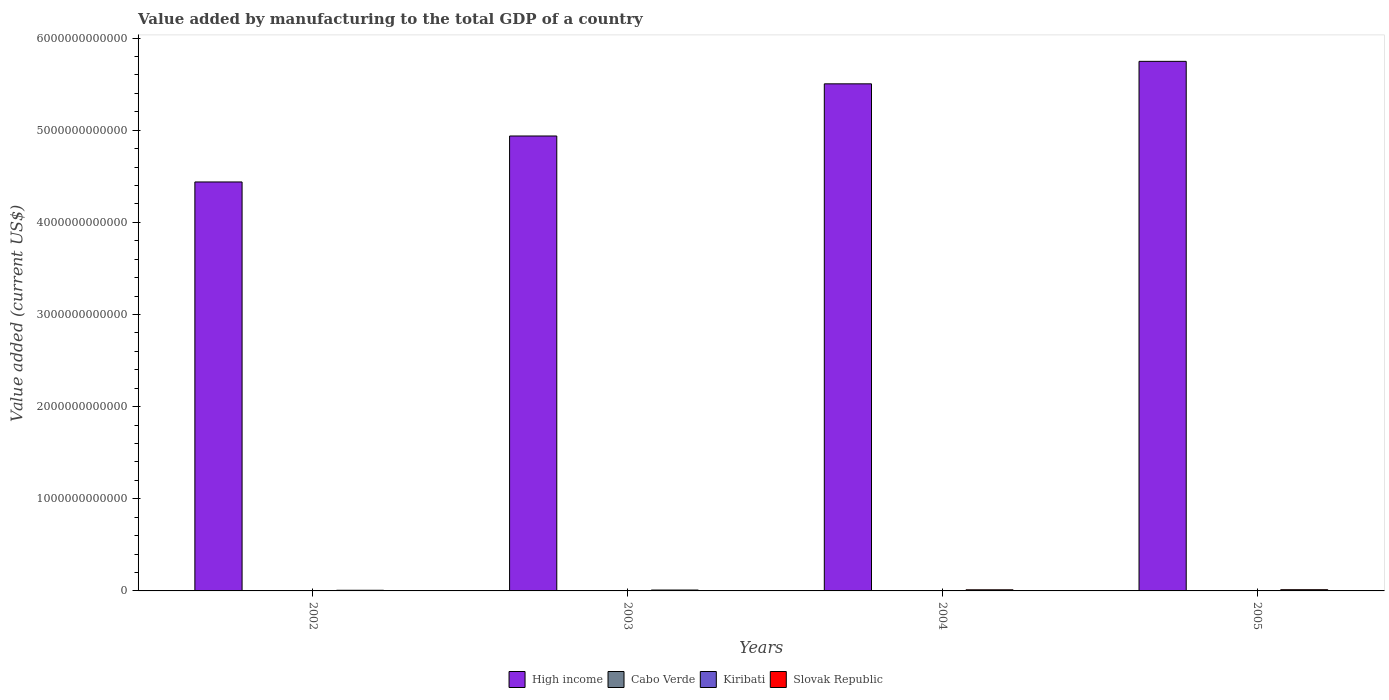How many different coloured bars are there?
Ensure brevity in your answer.  4. Are the number of bars per tick equal to the number of legend labels?
Your answer should be compact. Yes. How many bars are there on the 3rd tick from the left?
Offer a very short reply. 4. In how many cases, is the number of bars for a given year not equal to the number of legend labels?
Offer a terse response. 0. What is the value added by manufacturing to the total GDP in Kiribati in 2002?
Give a very brief answer. 2.85e+06. Across all years, what is the maximum value added by manufacturing to the total GDP in High income?
Your answer should be compact. 5.75e+12. Across all years, what is the minimum value added by manufacturing to the total GDP in Kiribati?
Your answer should be compact. 2.85e+06. What is the total value added by manufacturing to the total GDP in Cabo Verde in the graph?
Offer a terse response. 2.26e+08. What is the difference between the value added by manufacturing to the total GDP in Slovak Republic in 2004 and that in 2005?
Offer a very short reply. -1.05e+09. What is the difference between the value added by manufacturing to the total GDP in Slovak Republic in 2003 and the value added by manufacturing to the total GDP in Cabo Verde in 2002?
Offer a very short reply. 9.59e+09. What is the average value added by manufacturing to the total GDP in Slovak Republic per year?
Your response must be concise. 1.05e+1. In the year 2005, what is the difference between the value added by manufacturing to the total GDP in High income and value added by manufacturing to the total GDP in Cabo Verde?
Your answer should be very brief. 5.75e+12. What is the ratio of the value added by manufacturing to the total GDP in Kiribati in 2002 to that in 2003?
Offer a very short reply. 0.78. Is the value added by manufacturing to the total GDP in High income in 2004 less than that in 2005?
Your answer should be compact. Yes. What is the difference between the highest and the second highest value added by manufacturing to the total GDP in Slovak Republic?
Your response must be concise. 1.05e+09. What is the difference between the highest and the lowest value added by manufacturing to the total GDP in Cabo Verde?
Provide a succinct answer. 1.59e+07. In how many years, is the value added by manufacturing to the total GDP in Cabo Verde greater than the average value added by manufacturing to the total GDP in Cabo Verde taken over all years?
Give a very brief answer. 3. What does the 3rd bar from the left in 2005 represents?
Offer a very short reply. Kiribati. What does the 1st bar from the right in 2003 represents?
Provide a succinct answer. Slovak Republic. How many years are there in the graph?
Your response must be concise. 4. What is the difference between two consecutive major ticks on the Y-axis?
Keep it short and to the point. 1.00e+12. Are the values on the major ticks of Y-axis written in scientific E-notation?
Ensure brevity in your answer.  No. How are the legend labels stacked?
Your response must be concise. Horizontal. What is the title of the graph?
Your answer should be compact. Value added by manufacturing to the total GDP of a country. Does "Cameroon" appear as one of the legend labels in the graph?
Give a very brief answer. No. What is the label or title of the Y-axis?
Provide a short and direct response. Value added (current US$). What is the Value added (current US$) of High income in 2002?
Offer a very short reply. 4.44e+12. What is the Value added (current US$) in Cabo Verde in 2002?
Keep it short and to the point. 4.68e+07. What is the Value added (current US$) of Kiribati in 2002?
Give a very brief answer. 2.85e+06. What is the Value added (current US$) in Slovak Republic in 2002?
Provide a succinct answer. 7.10e+09. What is the Value added (current US$) in High income in 2003?
Offer a terse response. 4.94e+12. What is the Value added (current US$) of Cabo Verde in 2003?
Offer a very short reply. 5.70e+07. What is the Value added (current US$) in Kiribati in 2003?
Give a very brief answer. 3.66e+06. What is the Value added (current US$) in Slovak Republic in 2003?
Keep it short and to the point. 9.63e+09. What is the Value added (current US$) of High income in 2004?
Provide a short and direct response. 5.50e+12. What is the Value added (current US$) in Cabo Verde in 2004?
Your answer should be compact. 5.92e+07. What is the Value added (current US$) of Kiribati in 2004?
Your answer should be very brief. 4.54e+06. What is the Value added (current US$) of Slovak Republic in 2004?
Ensure brevity in your answer.  1.21e+1. What is the Value added (current US$) of High income in 2005?
Provide a short and direct response. 5.75e+12. What is the Value added (current US$) in Cabo Verde in 2005?
Ensure brevity in your answer.  6.27e+07. What is the Value added (current US$) in Kiribati in 2005?
Your answer should be very brief. 5.31e+06. What is the Value added (current US$) of Slovak Republic in 2005?
Make the answer very short. 1.31e+1. Across all years, what is the maximum Value added (current US$) of High income?
Your response must be concise. 5.75e+12. Across all years, what is the maximum Value added (current US$) in Cabo Verde?
Your answer should be compact. 6.27e+07. Across all years, what is the maximum Value added (current US$) in Kiribati?
Your response must be concise. 5.31e+06. Across all years, what is the maximum Value added (current US$) in Slovak Republic?
Offer a very short reply. 1.31e+1. Across all years, what is the minimum Value added (current US$) in High income?
Your answer should be compact. 4.44e+12. Across all years, what is the minimum Value added (current US$) of Cabo Verde?
Your answer should be very brief. 4.68e+07. Across all years, what is the minimum Value added (current US$) in Kiribati?
Your answer should be very brief. 2.85e+06. Across all years, what is the minimum Value added (current US$) of Slovak Republic?
Your answer should be very brief. 7.10e+09. What is the total Value added (current US$) of High income in the graph?
Your answer should be very brief. 2.06e+13. What is the total Value added (current US$) of Cabo Verde in the graph?
Keep it short and to the point. 2.26e+08. What is the total Value added (current US$) in Kiribati in the graph?
Make the answer very short. 1.64e+07. What is the total Value added (current US$) in Slovak Republic in the graph?
Keep it short and to the point. 4.19e+1. What is the difference between the Value added (current US$) in High income in 2002 and that in 2003?
Your answer should be very brief. -4.99e+11. What is the difference between the Value added (current US$) in Cabo Verde in 2002 and that in 2003?
Offer a terse response. -1.02e+07. What is the difference between the Value added (current US$) of Kiribati in 2002 and that in 2003?
Your answer should be very brief. -8.19e+05. What is the difference between the Value added (current US$) in Slovak Republic in 2002 and that in 2003?
Your answer should be compact. -2.53e+09. What is the difference between the Value added (current US$) of High income in 2002 and that in 2004?
Make the answer very short. -1.06e+12. What is the difference between the Value added (current US$) in Cabo Verde in 2002 and that in 2004?
Ensure brevity in your answer.  -1.24e+07. What is the difference between the Value added (current US$) of Kiribati in 2002 and that in 2004?
Offer a terse response. -1.69e+06. What is the difference between the Value added (current US$) of Slovak Republic in 2002 and that in 2004?
Your answer should be very brief. -4.96e+09. What is the difference between the Value added (current US$) of High income in 2002 and that in 2005?
Keep it short and to the point. -1.31e+12. What is the difference between the Value added (current US$) in Cabo Verde in 2002 and that in 2005?
Make the answer very short. -1.59e+07. What is the difference between the Value added (current US$) of Kiribati in 2002 and that in 2005?
Offer a very short reply. -2.47e+06. What is the difference between the Value added (current US$) of Slovak Republic in 2002 and that in 2005?
Provide a short and direct response. -6.01e+09. What is the difference between the Value added (current US$) of High income in 2003 and that in 2004?
Provide a short and direct response. -5.66e+11. What is the difference between the Value added (current US$) in Cabo Verde in 2003 and that in 2004?
Ensure brevity in your answer.  -2.22e+06. What is the difference between the Value added (current US$) in Kiribati in 2003 and that in 2004?
Your answer should be very brief. -8.74e+05. What is the difference between the Value added (current US$) in Slovak Republic in 2003 and that in 2004?
Make the answer very short. -2.42e+09. What is the difference between the Value added (current US$) of High income in 2003 and that in 2005?
Offer a very short reply. -8.10e+11. What is the difference between the Value added (current US$) of Cabo Verde in 2003 and that in 2005?
Your answer should be compact. -5.71e+06. What is the difference between the Value added (current US$) in Kiribati in 2003 and that in 2005?
Offer a terse response. -1.65e+06. What is the difference between the Value added (current US$) of Slovak Republic in 2003 and that in 2005?
Give a very brief answer. -3.47e+09. What is the difference between the Value added (current US$) in High income in 2004 and that in 2005?
Make the answer very short. -2.44e+11. What is the difference between the Value added (current US$) of Cabo Verde in 2004 and that in 2005?
Ensure brevity in your answer.  -3.49e+06. What is the difference between the Value added (current US$) of Kiribati in 2004 and that in 2005?
Your answer should be compact. -7.76e+05. What is the difference between the Value added (current US$) of Slovak Republic in 2004 and that in 2005?
Your answer should be very brief. -1.05e+09. What is the difference between the Value added (current US$) in High income in 2002 and the Value added (current US$) in Cabo Verde in 2003?
Provide a short and direct response. 4.44e+12. What is the difference between the Value added (current US$) of High income in 2002 and the Value added (current US$) of Kiribati in 2003?
Ensure brevity in your answer.  4.44e+12. What is the difference between the Value added (current US$) in High income in 2002 and the Value added (current US$) in Slovak Republic in 2003?
Your answer should be very brief. 4.43e+12. What is the difference between the Value added (current US$) of Cabo Verde in 2002 and the Value added (current US$) of Kiribati in 2003?
Offer a terse response. 4.32e+07. What is the difference between the Value added (current US$) in Cabo Verde in 2002 and the Value added (current US$) in Slovak Republic in 2003?
Make the answer very short. -9.59e+09. What is the difference between the Value added (current US$) in Kiribati in 2002 and the Value added (current US$) in Slovak Republic in 2003?
Make the answer very short. -9.63e+09. What is the difference between the Value added (current US$) in High income in 2002 and the Value added (current US$) in Cabo Verde in 2004?
Keep it short and to the point. 4.44e+12. What is the difference between the Value added (current US$) in High income in 2002 and the Value added (current US$) in Kiribati in 2004?
Keep it short and to the point. 4.44e+12. What is the difference between the Value added (current US$) in High income in 2002 and the Value added (current US$) in Slovak Republic in 2004?
Offer a terse response. 4.43e+12. What is the difference between the Value added (current US$) of Cabo Verde in 2002 and the Value added (current US$) of Kiribati in 2004?
Provide a short and direct response. 4.23e+07. What is the difference between the Value added (current US$) in Cabo Verde in 2002 and the Value added (current US$) in Slovak Republic in 2004?
Your answer should be compact. -1.20e+1. What is the difference between the Value added (current US$) in Kiribati in 2002 and the Value added (current US$) in Slovak Republic in 2004?
Keep it short and to the point. -1.21e+1. What is the difference between the Value added (current US$) of High income in 2002 and the Value added (current US$) of Cabo Verde in 2005?
Provide a succinct answer. 4.44e+12. What is the difference between the Value added (current US$) of High income in 2002 and the Value added (current US$) of Kiribati in 2005?
Keep it short and to the point. 4.44e+12. What is the difference between the Value added (current US$) of High income in 2002 and the Value added (current US$) of Slovak Republic in 2005?
Make the answer very short. 4.43e+12. What is the difference between the Value added (current US$) of Cabo Verde in 2002 and the Value added (current US$) of Kiribati in 2005?
Provide a succinct answer. 4.15e+07. What is the difference between the Value added (current US$) of Cabo Verde in 2002 and the Value added (current US$) of Slovak Republic in 2005?
Keep it short and to the point. -1.31e+1. What is the difference between the Value added (current US$) in Kiribati in 2002 and the Value added (current US$) in Slovak Republic in 2005?
Your response must be concise. -1.31e+1. What is the difference between the Value added (current US$) in High income in 2003 and the Value added (current US$) in Cabo Verde in 2004?
Your answer should be very brief. 4.94e+12. What is the difference between the Value added (current US$) in High income in 2003 and the Value added (current US$) in Kiribati in 2004?
Offer a very short reply. 4.94e+12. What is the difference between the Value added (current US$) in High income in 2003 and the Value added (current US$) in Slovak Republic in 2004?
Give a very brief answer. 4.93e+12. What is the difference between the Value added (current US$) of Cabo Verde in 2003 and the Value added (current US$) of Kiribati in 2004?
Keep it short and to the point. 5.25e+07. What is the difference between the Value added (current US$) of Cabo Verde in 2003 and the Value added (current US$) of Slovak Republic in 2004?
Ensure brevity in your answer.  -1.20e+1. What is the difference between the Value added (current US$) in Kiribati in 2003 and the Value added (current US$) in Slovak Republic in 2004?
Your answer should be compact. -1.21e+1. What is the difference between the Value added (current US$) in High income in 2003 and the Value added (current US$) in Cabo Verde in 2005?
Make the answer very short. 4.94e+12. What is the difference between the Value added (current US$) in High income in 2003 and the Value added (current US$) in Kiribati in 2005?
Your answer should be compact. 4.94e+12. What is the difference between the Value added (current US$) of High income in 2003 and the Value added (current US$) of Slovak Republic in 2005?
Your answer should be very brief. 4.92e+12. What is the difference between the Value added (current US$) in Cabo Verde in 2003 and the Value added (current US$) in Kiribati in 2005?
Your answer should be compact. 5.17e+07. What is the difference between the Value added (current US$) of Cabo Verde in 2003 and the Value added (current US$) of Slovak Republic in 2005?
Provide a succinct answer. -1.31e+1. What is the difference between the Value added (current US$) of Kiribati in 2003 and the Value added (current US$) of Slovak Republic in 2005?
Keep it short and to the point. -1.31e+1. What is the difference between the Value added (current US$) of High income in 2004 and the Value added (current US$) of Cabo Verde in 2005?
Your answer should be very brief. 5.50e+12. What is the difference between the Value added (current US$) in High income in 2004 and the Value added (current US$) in Kiribati in 2005?
Provide a short and direct response. 5.50e+12. What is the difference between the Value added (current US$) in High income in 2004 and the Value added (current US$) in Slovak Republic in 2005?
Give a very brief answer. 5.49e+12. What is the difference between the Value added (current US$) in Cabo Verde in 2004 and the Value added (current US$) in Kiribati in 2005?
Make the answer very short. 5.39e+07. What is the difference between the Value added (current US$) in Cabo Verde in 2004 and the Value added (current US$) in Slovak Republic in 2005?
Offer a terse response. -1.30e+1. What is the difference between the Value added (current US$) in Kiribati in 2004 and the Value added (current US$) in Slovak Republic in 2005?
Provide a short and direct response. -1.31e+1. What is the average Value added (current US$) of High income per year?
Give a very brief answer. 5.16e+12. What is the average Value added (current US$) of Cabo Verde per year?
Ensure brevity in your answer.  5.65e+07. What is the average Value added (current US$) in Kiribati per year?
Provide a short and direct response. 4.09e+06. What is the average Value added (current US$) in Slovak Republic per year?
Provide a succinct answer. 1.05e+1. In the year 2002, what is the difference between the Value added (current US$) of High income and Value added (current US$) of Cabo Verde?
Provide a succinct answer. 4.44e+12. In the year 2002, what is the difference between the Value added (current US$) in High income and Value added (current US$) in Kiribati?
Offer a terse response. 4.44e+12. In the year 2002, what is the difference between the Value added (current US$) of High income and Value added (current US$) of Slovak Republic?
Your response must be concise. 4.43e+12. In the year 2002, what is the difference between the Value added (current US$) in Cabo Verde and Value added (current US$) in Kiribati?
Provide a succinct answer. 4.40e+07. In the year 2002, what is the difference between the Value added (current US$) in Cabo Verde and Value added (current US$) in Slovak Republic?
Offer a terse response. -7.05e+09. In the year 2002, what is the difference between the Value added (current US$) of Kiribati and Value added (current US$) of Slovak Republic?
Make the answer very short. -7.10e+09. In the year 2003, what is the difference between the Value added (current US$) in High income and Value added (current US$) in Cabo Verde?
Keep it short and to the point. 4.94e+12. In the year 2003, what is the difference between the Value added (current US$) of High income and Value added (current US$) of Kiribati?
Ensure brevity in your answer.  4.94e+12. In the year 2003, what is the difference between the Value added (current US$) in High income and Value added (current US$) in Slovak Republic?
Your answer should be compact. 4.93e+12. In the year 2003, what is the difference between the Value added (current US$) of Cabo Verde and Value added (current US$) of Kiribati?
Keep it short and to the point. 5.34e+07. In the year 2003, what is the difference between the Value added (current US$) in Cabo Verde and Value added (current US$) in Slovak Republic?
Offer a terse response. -9.58e+09. In the year 2003, what is the difference between the Value added (current US$) of Kiribati and Value added (current US$) of Slovak Republic?
Your response must be concise. -9.63e+09. In the year 2004, what is the difference between the Value added (current US$) of High income and Value added (current US$) of Cabo Verde?
Offer a very short reply. 5.50e+12. In the year 2004, what is the difference between the Value added (current US$) in High income and Value added (current US$) in Kiribati?
Provide a short and direct response. 5.50e+12. In the year 2004, what is the difference between the Value added (current US$) in High income and Value added (current US$) in Slovak Republic?
Make the answer very short. 5.49e+12. In the year 2004, what is the difference between the Value added (current US$) in Cabo Verde and Value added (current US$) in Kiribati?
Offer a very short reply. 5.47e+07. In the year 2004, what is the difference between the Value added (current US$) in Cabo Verde and Value added (current US$) in Slovak Republic?
Your answer should be very brief. -1.20e+1. In the year 2004, what is the difference between the Value added (current US$) of Kiribati and Value added (current US$) of Slovak Republic?
Keep it short and to the point. -1.21e+1. In the year 2005, what is the difference between the Value added (current US$) in High income and Value added (current US$) in Cabo Verde?
Your answer should be very brief. 5.75e+12. In the year 2005, what is the difference between the Value added (current US$) of High income and Value added (current US$) of Kiribati?
Give a very brief answer. 5.75e+12. In the year 2005, what is the difference between the Value added (current US$) of High income and Value added (current US$) of Slovak Republic?
Give a very brief answer. 5.74e+12. In the year 2005, what is the difference between the Value added (current US$) of Cabo Verde and Value added (current US$) of Kiribati?
Your response must be concise. 5.74e+07. In the year 2005, what is the difference between the Value added (current US$) in Cabo Verde and Value added (current US$) in Slovak Republic?
Make the answer very short. -1.30e+1. In the year 2005, what is the difference between the Value added (current US$) of Kiribati and Value added (current US$) of Slovak Republic?
Give a very brief answer. -1.31e+1. What is the ratio of the Value added (current US$) of High income in 2002 to that in 2003?
Offer a very short reply. 0.9. What is the ratio of the Value added (current US$) of Cabo Verde in 2002 to that in 2003?
Keep it short and to the point. 0.82. What is the ratio of the Value added (current US$) in Kiribati in 2002 to that in 2003?
Provide a short and direct response. 0.78. What is the ratio of the Value added (current US$) of Slovak Republic in 2002 to that in 2003?
Your answer should be very brief. 0.74. What is the ratio of the Value added (current US$) in High income in 2002 to that in 2004?
Ensure brevity in your answer.  0.81. What is the ratio of the Value added (current US$) of Cabo Verde in 2002 to that in 2004?
Keep it short and to the point. 0.79. What is the ratio of the Value added (current US$) in Kiribati in 2002 to that in 2004?
Keep it short and to the point. 0.63. What is the ratio of the Value added (current US$) in Slovak Republic in 2002 to that in 2004?
Provide a short and direct response. 0.59. What is the ratio of the Value added (current US$) of High income in 2002 to that in 2005?
Keep it short and to the point. 0.77. What is the ratio of the Value added (current US$) of Cabo Verde in 2002 to that in 2005?
Offer a very short reply. 0.75. What is the ratio of the Value added (current US$) in Kiribati in 2002 to that in 2005?
Offer a terse response. 0.54. What is the ratio of the Value added (current US$) of Slovak Republic in 2002 to that in 2005?
Provide a short and direct response. 0.54. What is the ratio of the Value added (current US$) in High income in 2003 to that in 2004?
Ensure brevity in your answer.  0.9. What is the ratio of the Value added (current US$) of Cabo Verde in 2003 to that in 2004?
Provide a succinct answer. 0.96. What is the ratio of the Value added (current US$) in Kiribati in 2003 to that in 2004?
Provide a succinct answer. 0.81. What is the ratio of the Value added (current US$) of Slovak Republic in 2003 to that in 2004?
Ensure brevity in your answer.  0.8. What is the ratio of the Value added (current US$) in High income in 2003 to that in 2005?
Give a very brief answer. 0.86. What is the ratio of the Value added (current US$) in Cabo Verde in 2003 to that in 2005?
Offer a very short reply. 0.91. What is the ratio of the Value added (current US$) in Kiribati in 2003 to that in 2005?
Offer a terse response. 0.69. What is the ratio of the Value added (current US$) in Slovak Republic in 2003 to that in 2005?
Ensure brevity in your answer.  0.73. What is the ratio of the Value added (current US$) of High income in 2004 to that in 2005?
Offer a terse response. 0.96. What is the ratio of the Value added (current US$) in Cabo Verde in 2004 to that in 2005?
Your response must be concise. 0.94. What is the ratio of the Value added (current US$) in Kiribati in 2004 to that in 2005?
Provide a succinct answer. 0.85. What is the ratio of the Value added (current US$) of Slovak Republic in 2004 to that in 2005?
Offer a terse response. 0.92. What is the difference between the highest and the second highest Value added (current US$) of High income?
Provide a succinct answer. 2.44e+11. What is the difference between the highest and the second highest Value added (current US$) of Cabo Verde?
Your response must be concise. 3.49e+06. What is the difference between the highest and the second highest Value added (current US$) in Kiribati?
Provide a short and direct response. 7.76e+05. What is the difference between the highest and the second highest Value added (current US$) of Slovak Republic?
Provide a succinct answer. 1.05e+09. What is the difference between the highest and the lowest Value added (current US$) of High income?
Offer a very short reply. 1.31e+12. What is the difference between the highest and the lowest Value added (current US$) in Cabo Verde?
Provide a short and direct response. 1.59e+07. What is the difference between the highest and the lowest Value added (current US$) in Kiribati?
Make the answer very short. 2.47e+06. What is the difference between the highest and the lowest Value added (current US$) in Slovak Republic?
Your answer should be very brief. 6.01e+09. 